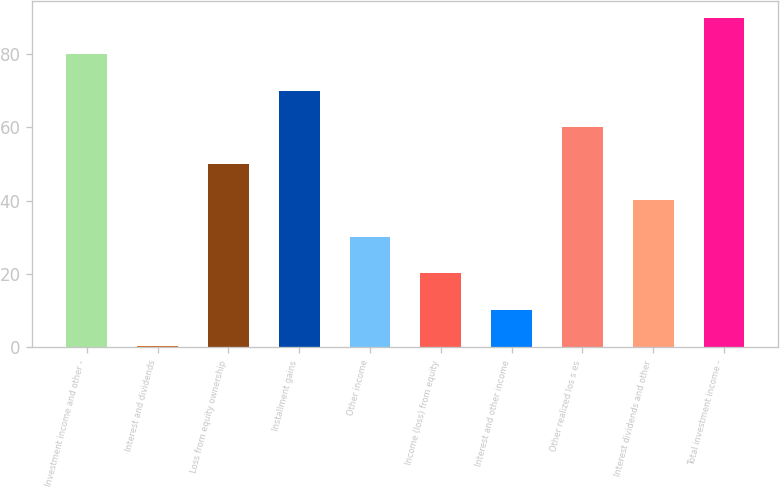Convert chart to OTSL. <chart><loc_0><loc_0><loc_500><loc_500><bar_chart><fcel>Investment income and other -<fcel>Interest and dividends<fcel>Loss from equity ownership<fcel>Installment gains<fcel>Other income<fcel>Income (loss) from equity<fcel>Interest and other income<fcel>Other realized los s es<fcel>Interest dividends and other<fcel>Total investment income -<nl><fcel>79.9<fcel>0.3<fcel>50.05<fcel>69.95<fcel>30.15<fcel>20.2<fcel>10.25<fcel>60<fcel>40.1<fcel>89.85<nl></chart> 